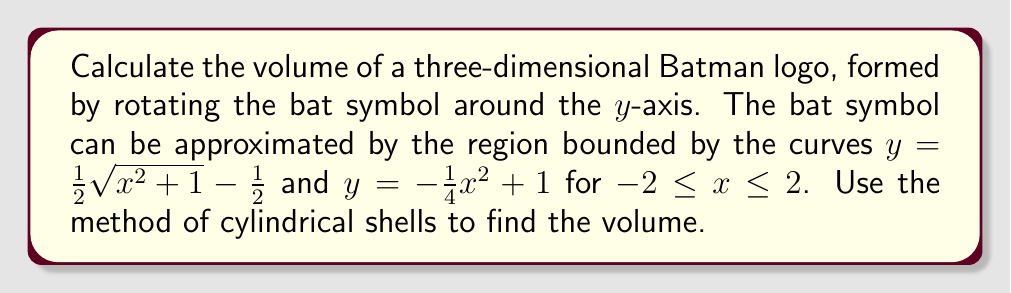Show me your answer to this math problem. Let's approach this step-by-step:

1) The method of cylindrical shells uses the formula:
   $$V = 2\pi \int_{a}^{b} x[f(x) - g(x)] dx$$
   where $f(x)$ is the outer function and $g(x)$ is the inner function.

2) In our case:
   $f(x) = -\frac{1}{4}x^2 + 1$
   $g(x) = \frac{1}{2}\sqrt{x^2 + 1} - \frac{1}{2}$
   $a = -2$ and $b = 2$

3) Substituting into the formula:
   $$V = 2\pi \int_{-2}^{2} x[(-\frac{1}{4}x^2 + 1) - (\frac{1}{2}\sqrt{x^2 + 1} - \frac{1}{2})] dx$$

4) Simplifying the integrand:
   $$V = 2\pi \int_{-2}^{2} x[-\frac{1}{4}x^2 + \frac{3}{2} - \frac{1}{2}\sqrt{x^2 + 1}] dx$$

5) This integral is quite complex. We can split it into three parts:
   $$V = 2\pi [\int_{-2}^{2} -\frac{1}{4}x^3 dx + \int_{-2}^{2} \frac{3}{2}x dx - \int_{-2}^{2} \frac{1}{2}x\sqrt{x^2 + 1} dx]$$

6) Evaluating each integral:
   - $\int_{-2}^{2} -\frac{1}{4}x^3 dx = [-\frac{1}{16}x^4]_{-2}^{2} = 0$
   - $\int_{-2}^{2} \frac{3}{2}x dx = [\frac{3}{4}x^2]_{-2}^{2} = 6$
   - The third integral is more complex and requires substitution. Let $u = x^2 + 1$, then $du = 2x dx$:
     $\int_{-2}^{2} \frac{1}{2}x\sqrt{x^2 + 1} dx = \frac{1}{4}\int_{5}^{5} \sqrt{u} du = \frac{1}{6}[u^{3/2}]_{5}^{5} = 0$

7) Therefore:
   $$V = 2\pi [0 + 6 - 0] = 12\pi$$

[asy]
import graph;
size(200);
real f(real x) {return -0.25*x^2 + 1;}
real g(real x) {return 0.5*sqrt(x^2 + 1) - 0.5;}
draw(graph(f,-2,2), blue);
draw(graph(g,-2,2), red);
xaxis("x");
yaxis("y");
label("$y=-\frac{1}{4}x^2+1$", (2,f(2)), E, blue);
label("$y=\frac{1}{2}\sqrt{x^2+1}-\frac{1}{2}$", (-2,g(-2)), W, red);
[/asy]
Answer: $12\pi$ cubic units 